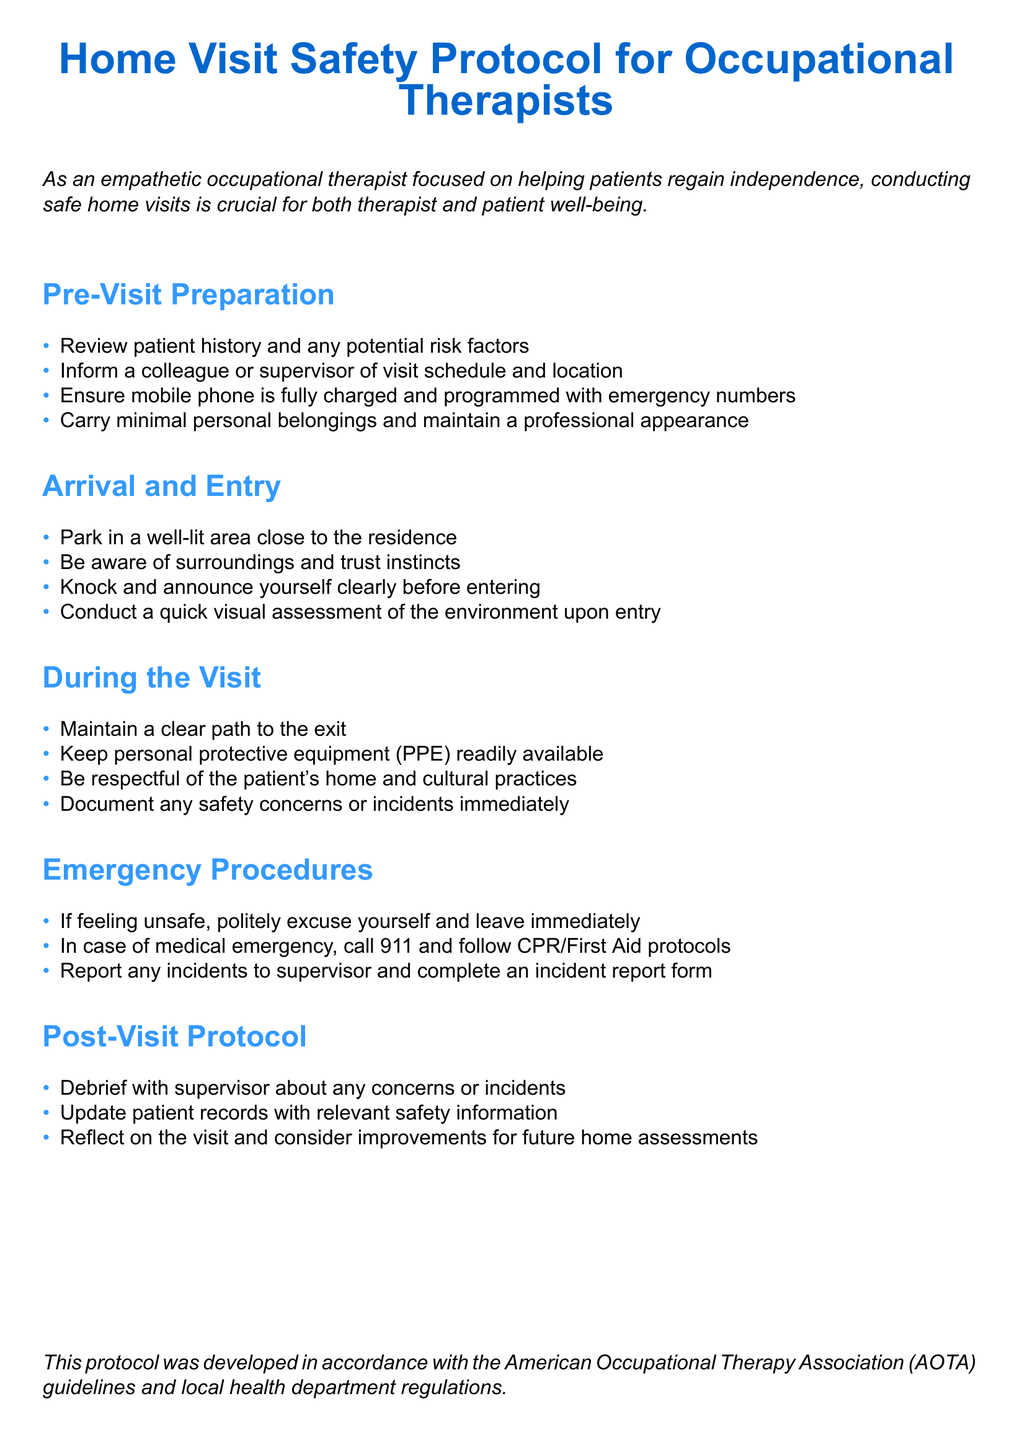What is the main focus of the protocol? The main focus of the protocol is the safety of both the therapist and patient during home visits.
Answer: Safety of both therapist and patient How many sections are in the document? The document consists of five sections detailing different aspects of the safety protocol.
Answer: Five sections What should be reviewed before the visit? Occupational therapists are advised to review patient history and any potential risk factors before the visit.
Answer: Patient history and potential risk factors What emergency number should therapists be prepared to call? In case of a medical emergency, therapists should be prepared to call 911.
Answer: 911 What should a therapist do if they feel unsafe during a visit? If feeling unsafe, the therapist should politely excuse themselves and leave immediately.
Answer: Leave immediately What should be updated after the visit? After the visit, patient records should be updated with relevant safety information.
Answer: Patient records Which organization's guidelines were followed in developing the protocol? The protocol was developed in accordance with the American Occupational Therapy Association guidelines.
Answer: American Occupational Therapy Association How should personal belongings be managed during the visit? Therapists should carry minimal personal belongings and maintain a professional appearance during the visit.
Answer: Minimal personal belongings What type of assessment should be conducted upon entering the residence? A quick visual assessment of the environment should be conducted upon entry.
Answer: Quick visual assessment 